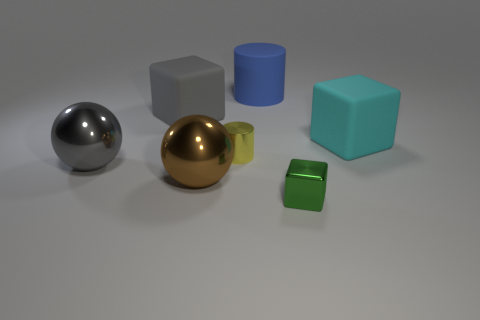What material is the big cube that is behind the cyan thing? Based on the appearance in the image, the big cube behind the cyan cylinder seems to have a matte finish, which could be indicative of rubber or a rubber-like material. However, without being able to physically touch or examine the cube, it's not possible to determine the material with absolute certainty from the image alone. 